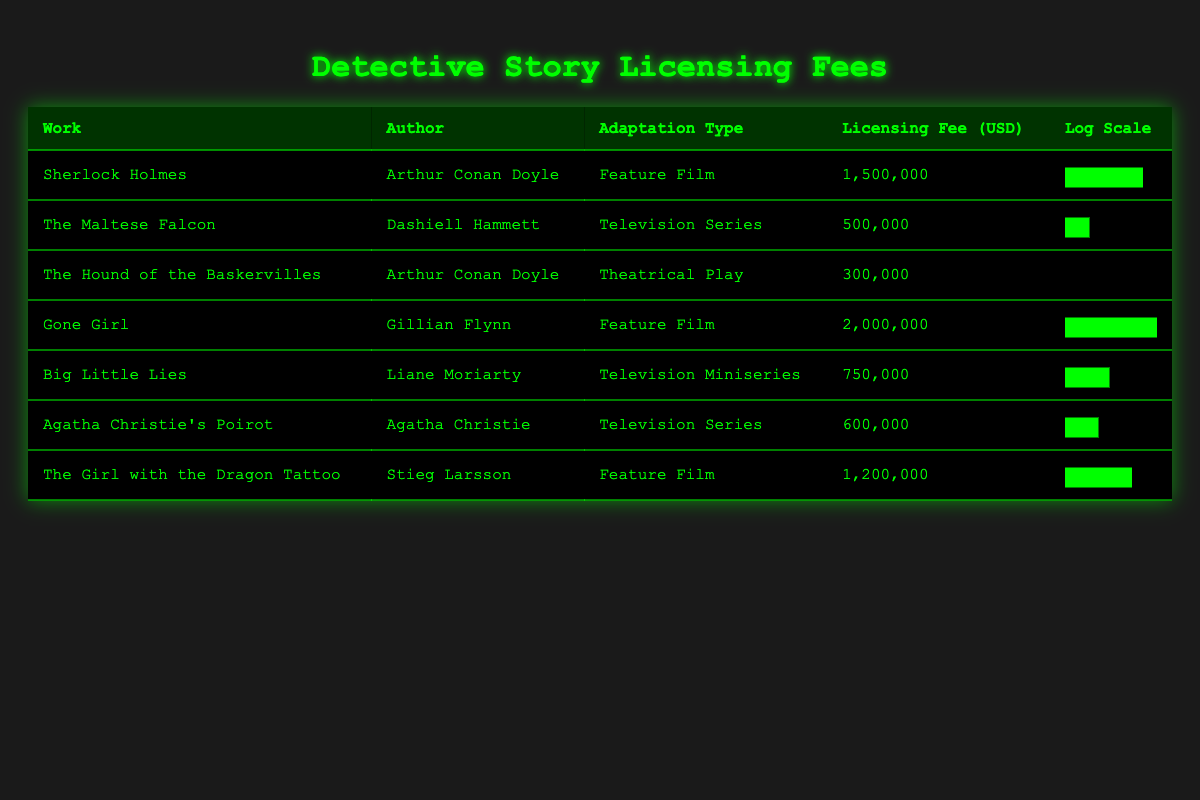What is the licensing fee for "Gone Girl"? The table directly lists the licensing fee for "Gone Girl" as 2,000,000 USD under the "Licensing Fee (USD)" column.
Answer: 2,000,000 Who is the author of "The Hound of the Baskervilles"? The author of "The Hound of the Baskervilles" is found in the second column of the corresponding row, which states that Arthur Conan Doyle is the author.
Answer: Arthur Conan Doyle Which adaptation type has the highest licensing fee? To find this, check the "Licensing Fee (USD)" column for all adaptation types. "Gone Girl" as a Feature Film has the highest fee at 2,000,000 USD.
Answer: Feature Film What is the average licensing fee for all adaptations listed? The licensing fees are 1,500,000; 500,000; 300,000; 2,000,000; 750,000; 600,000; 1,200,000. Sum: 7,850,000. There are 7 adaptations, so the average is 7,850,000 divided by 7, which equals approximately 1,121,429.
Answer: 1,121,429 Is the licensing fee for "Agatha Christie's Poirot" greater than 500,000 USD? The table shows that the licensing fee for "Agatha Christie's Poirot" is 600,000 USD. Since 600,000 is greater than 500,000, the answer is yes.
Answer: Yes What is the total licensing fee for adaptations by Arthur Conan Doyle? The two adaptations by Arthur Conan Doyle are "Sherlock Holmes" (1,500,000) and "The Hound of the Baskervilles" (300,000). Adding these, 1,500,000 + 300,000 equals 1,800,000.
Answer: 1,800,000 How many adaptations listed have a licensing fee between 500,000 and 1,500,000 USD? Review the licensing fees: "The Maltese Falcon" (500,000), "Agatha Christie's Poirot" (600,000), "Big Little Lies" (750,000), "The Girl with the Dragon Tattoo" (1,200,000). Count these adaptations: there are 4 within this range.
Answer: 4 Which adaptation type has the lowest licensing fee? By examining the "Licensing Fee (USD)" column, "The Hound of the Baskervilles" as a Theatrical Play shows the lowest fee at 300,000 USD.
Answer: Theatrical Play 